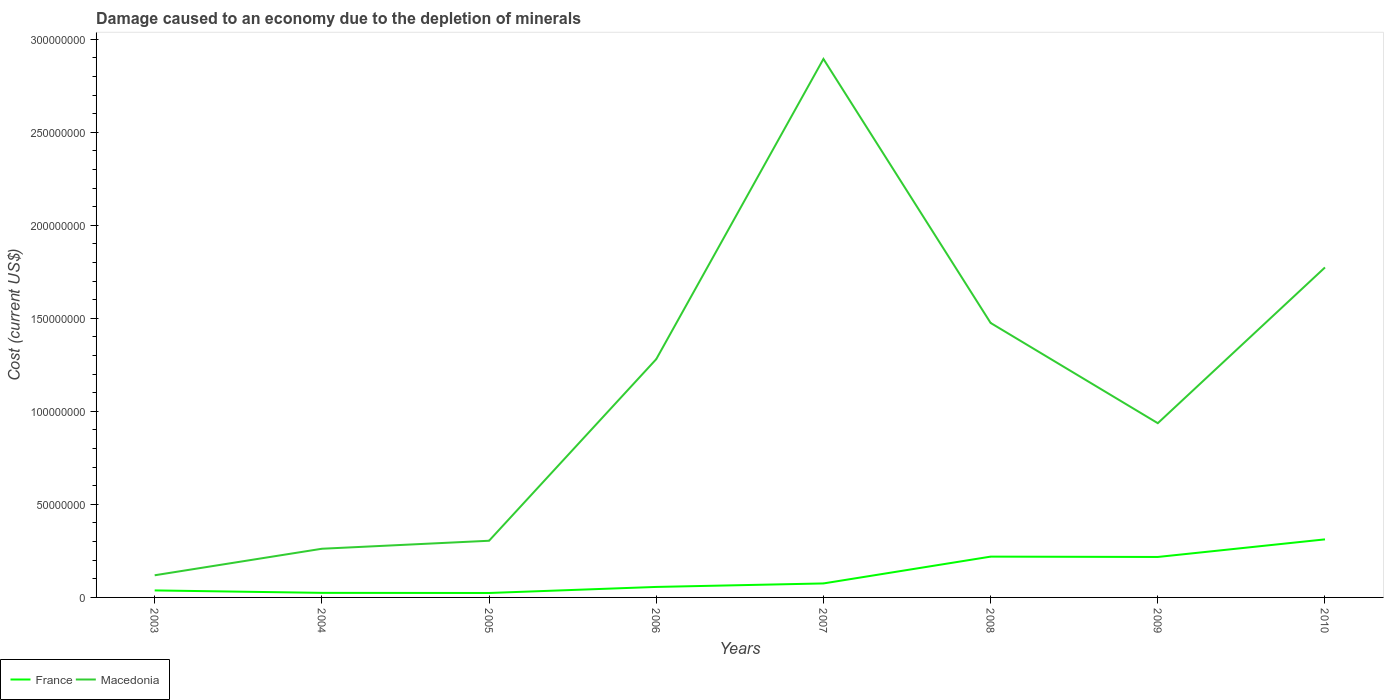Across all years, what is the maximum cost of damage caused due to the depletion of minerals in Macedonia?
Ensure brevity in your answer.  1.19e+07. What is the total cost of damage caused due to the depletion of minerals in France in the graph?
Provide a short and direct response. -3.75e+06. What is the difference between the highest and the second highest cost of damage caused due to the depletion of minerals in France?
Make the answer very short. 2.88e+07. Is the cost of damage caused due to the depletion of minerals in France strictly greater than the cost of damage caused due to the depletion of minerals in Macedonia over the years?
Your response must be concise. Yes. How many years are there in the graph?
Your response must be concise. 8. What is the difference between two consecutive major ticks on the Y-axis?
Offer a terse response. 5.00e+07. Are the values on the major ticks of Y-axis written in scientific E-notation?
Offer a terse response. No. Where does the legend appear in the graph?
Your response must be concise. Bottom left. How many legend labels are there?
Provide a succinct answer. 2. What is the title of the graph?
Give a very brief answer. Damage caused to an economy due to the depletion of minerals. Does "St. Vincent and the Grenadines" appear as one of the legend labels in the graph?
Provide a succinct answer. No. What is the label or title of the Y-axis?
Your answer should be compact. Cost (current US$). What is the Cost (current US$) in France in 2003?
Your answer should be very brief. 3.77e+06. What is the Cost (current US$) in Macedonia in 2003?
Your answer should be compact. 1.19e+07. What is the Cost (current US$) in France in 2004?
Give a very brief answer. 2.46e+06. What is the Cost (current US$) of Macedonia in 2004?
Make the answer very short. 2.62e+07. What is the Cost (current US$) in France in 2005?
Your answer should be compact. 2.39e+06. What is the Cost (current US$) in Macedonia in 2005?
Offer a terse response. 3.05e+07. What is the Cost (current US$) of France in 2006?
Offer a terse response. 5.64e+06. What is the Cost (current US$) of Macedonia in 2006?
Your answer should be compact. 1.28e+08. What is the Cost (current US$) of France in 2007?
Offer a very short reply. 7.52e+06. What is the Cost (current US$) in Macedonia in 2007?
Offer a very short reply. 2.89e+08. What is the Cost (current US$) of France in 2008?
Provide a short and direct response. 2.19e+07. What is the Cost (current US$) of Macedonia in 2008?
Offer a very short reply. 1.48e+08. What is the Cost (current US$) of France in 2009?
Offer a terse response. 2.17e+07. What is the Cost (current US$) of Macedonia in 2009?
Provide a short and direct response. 9.36e+07. What is the Cost (current US$) of France in 2010?
Make the answer very short. 3.12e+07. What is the Cost (current US$) of Macedonia in 2010?
Provide a short and direct response. 1.77e+08. Across all years, what is the maximum Cost (current US$) of France?
Your answer should be compact. 3.12e+07. Across all years, what is the maximum Cost (current US$) in Macedonia?
Your answer should be compact. 2.89e+08. Across all years, what is the minimum Cost (current US$) in France?
Ensure brevity in your answer.  2.39e+06. Across all years, what is the minimum Cost (current US$) in Macedonia?
Offer a terse response. 1.19e+07. What is the total Cost (current US$) of France in the graph?
Provide a short and direct response. 9.66e+07. What is the total Cost (current US$) of Macedonia in the graph?
Offer a very short reply. 9.04e+08. What is the difference between the Cost (current US$) of France in 2003 and that in 2004?
Your answer should be compact. 1.31e+06. What is the difference between the Cost (current US$) in Macedonia in 2003 and that in 2004?
Give a very brief answer. -1.43e+07. What is the difference between the Cost (current US$) of France in 2003 and that in 2005?
Provide a short and direct response. 1.38e+06. What is the difference between the Cost (current US$) in Macedonia in 2003 and that in 2005?
Your answer should be very brief. -1.86e+07. What is the difference between the Cost (current US$) in France in 2003 and that in 2006?
Offer a terse response. -1.88e+06. What is the difference between the Cost (current US$) of Macedonia in 2003 and that in 2006?
Your answer should be very brief. -1.16e+08. What is the difference between the Cost (current US$) in France in 2003 and that in 2007?
Keep it short and to the point. -3.75e+06. What is the difference between the Cost (current US$) of Macedonia in 2003 and that in 2007?
Keep it short and to the point. -2.77e+08. What is the difference between the Cost (current US$) in France in 2003 and that in 2008?
Offer a terse response. -1.82e+07. What is the difference between the Cost (current US$) in Macedonia in 2003 and that in 2008?
Give a very brief answer. -1.36e+08. What is the difference between the Cost (current US$) in France in 2003 and that in 2009?
Your answer should be very brief. -1.80e+07. What is the difference between the Cost (current US$) of Macedonia in 2003 and that in 2009?
Provide a short and direct response. -8.17e+07. What is the difference between the Cost (current US$) in France in 2003 and that in 2010?
Your answer should be very brief. -2.74e+07. What is the difference between the Cost (current US$) in Macedonia in 2003 and that in 2010?
Your answer should be very brief. -1.65e+08. What is the difference between the Cost (current US$) in France in 2004 and that in 2005?
Give a very brief answer. 7.20e+04. What is the difference between the Cost (current US$) of Macedonia in 2004 and that in 2005?
Ensure brevity in your answer.  -4.30e+06. What is the difference between the Cost (current US$) of France in 2004 and that in 2006?
Offer a very short reply. -3.18e+06. What is the difference between the Cost (current US$) in Macedonia in 2004 and that in 2006?
Make the answer very short. -1.02e+08. What is the difference between the Cost (current US$) of France in 2004 and that in 2007?
Your answer should be very brief. -5.06e+06. What is the difference between the Cost (current US$) in Macedonia in 2004 and that in 2007?
Provide a short and direct response. -2.63e+08. What is the difference between the Cost (current US$) in France in 2004 and that in 2008?
Provide a succinct answer. -1.95e+07. What is the difference between the Cost (current US$) of Macedonia in 2004 and that in 2008?
Your answer should be compact. -1.21e+08. What is the difference between the Cost (current US$) of France in 2004 and that in 2009?
Your answer should be compact. -1.93e+07. What is the difference between the Cost (current US$) in Macedonia in 2004 and that in 2009?
Provide a succinct answer. -6.75e+07. What is the difference between the Cost (current US$) of France in 2004 and that in 2010?
Provide a short and direct response. -2.87e+07. What is the difference between the Cost (current US$) in Macedonia in 2004 and that in 2010?
Your answer should be compact. -1.51e+08. What is the difference between the Cost (current US$) in France in 2005 and that in 2006?
Provide a succinct answer. -3.25e+06. What is the difference between the Cost (current US$) in Macedonia in 2005 and that in 2006?
Make the answer very short. -9.76e+07. What is the difference between the Cost (current US$) of France in 2005 and that in 2007?
Provide a succinct answer. -5.13e+06. What is the difference between the Cost (current US$) of Macedonia in 2005 and that in 2007?
Ensure brevity in your answer.  -2.59e+08. What is the difference between the Cost (current US$) in France in 2005 and that in 2008?
Keep it short and to the point. -1.95e+07. What is the difference between the Cost (current US$) of Macedonia in 2005 and that in 2008?
Your response must be concise. -1.17e+08. What is the difference between the Cost (current US$) of France in 2005 and that in 2009?
Offer a very short reply. -1.94e+07. What is the difference between the Cost (current US$) in Macedonia in 2005 and that in 2009?
Provide a succinct answer. -6.32e+07. What is the difference between the Cost (current US$) of France in 2005 and that in 2010?
Your answer should be very brief. -2.88e+07. What is the difference between the Cost (current US$) in Macedonia in 2005 and that in 2010?
Give a very brief answer. -1.47e+08. What is the difference between the Cost (current US$) of France in 2006 and that in 2007?
Offer a very short reply. -1.87e+06. What is the difference between the Cost (current US$) in Macedonia in 2006 and that in 2007?
Your response must be concise. -1.61e+08. What is the difference between the Cost (current US$) in France in 2006 and that in 2008?
Your response must be concise. -1.63e+07. What is the difference between the Cost (current US$) in Macedonia in 2006 and that in 2008?
Offer a terse response. -1.95e+07. What is the difference between the Cost (current US$) of France in 2006 and that in 2009?
Provide a succinct answer. -1.61e+07. What is the difference between the Cost (current US$) of Macedonia in 2006 and that in 2009?
Provide a short and direct response. 3.44e+07. What is the difference between the Cost (current US$) in France in 2006 and that in 2010?
Offer a terse response. -2.56e+07. What is the difference between the Cost (current US$) in Macedonia in 2006 and that in 2010?
Your answer should be compact. -4.93e+07. What is the difference between the Cost (current US$) in France in 2007 and that in 2008?
Your response must be concise. -1.44e+07. What is the difference between the Cost (current US$) of Macedonia in 2007 and that in 2008?
Make the answer very short. 1.42e+08. What is the difference between the Cost (current US$) of France in 2007 and that in 2009?
Your response must be concise. -1.42e+07. What is the difference between the Cost (current US$) of Macedonia in 2007 and that in 2009?
Offer a very short reply. 1.96e+08. What is the difference between the Cost (current US$) of France in 2007 and that in 2010?
Provide a short and direct response. -2.37e+07. What is the difference between the Cost (current US$) of Macedonia in 2007 and that in 2010?
Your response must be concise. 1.12e+08. What is the difference between the Cost (current US$) in France in 2008 and that in 2009?
Make the answer very short. 1.81e+05. What is the difference between the Cost (current US$) of Macedonia in 2008 and that in 2009?
Offer a terse response. 5.39e+07. What is the difference between the Cost (current US$) in France in 2008 and that in 2010?
Provide a short and direct response. -9.28e+06. What is the difference between the Cost (current US$) in Macedonia in 2008 and that in 2010?
Ensure brevity in your answer.  -2.98e+07. What is the difference between the Cost (current US$) of France in 2009 and that in 2010?
Offer a very short reply. -9.46e+06. What is the difference between the Cost (current US$) of Macedonia in 2009 and that in 2010?
Your response must be concise. -8.37e+07. What is the difference between the Cost (current US$) of France in 2003 and the Cost (current US$) of Macedonia in 2004?
Offer a terse response. -2.24e+07. What is the difference between the Cost (current US$) of France in 2003 and the Cost (current US$) of Macedonia in 2005?
Your answer should be very brief. -2.67e+07. What is the difference between the Cost (current US$) in France in 2003 and the Cost (current US$) in Macedonia in 2006?
Offer a terse response. -1.24e+08. What is the difference between the Cost (current US$) in France in 2003 and the Cost (current US$) in Macedonia in 2007?
Provide a short and direct response. -2.86e+08. What is the difference between the Cost (current US$) in France in 2003 and the Cost (current US$) in Macedonia in 2008?
Your answer should be compact. -1.44e+08. What is the difference between the Cost (current US$) of France in 2003 and the Cost (current US$) of Macedonia in 2009?
Provide a succinct answer. -8.99e+07. What is the difference between the Cost (current US$) of France in 2003 and the Cost (current US$) of Macedonia in 2010?
Offer a very short reply. -1.74e+08. What is the difference between the Cost (current US$) in France in 2004 and the Cost (current US$) in Macedonia in 2005?
Offer a very short reply. -2.80e+07. What is the difference between the Cost (current US$) of France in 2004 and the Cost (current US$) of Macedonia in 2006?
Provide a short and direct response. -1.26e+08. What is the difference between the Cost (current US$) in France in 2004 and the Cost (current US$) in Macedonia in 2007?
Offer a terse response. -2.87e+08. What is the difference between the Cost (current US$) of France in 2004 and the Cost (current US$) of Macedonia in 2008?
Make the answer very short. -1.45e+08. What is the difference between the Cost (current US$) in France in 2004 and the Cost (current US$) in Macedonia in 2009?
Give a very brief answer. -9.12e+07. What is the difference between the Cost (current US$) in France in 2004 and the Cost (current US$) in Macedonia in 2010?
Make the answer very short. -1.75e+08. What is the difference between the Cost (current US$) in France in 2005 and the Cost (current US$) in Macedonia in 2006?
Keep it short and to the point. -1.26e+08. What is the difference between the Cost (current US$) in France in 2005 and the Cost (current US$) in Macedonia in 2007?
Provide a short and direct response. -2.87e+08. What is the difference between the Cost (current US$) in France in 2005 and the Cost (current US$) in Macedonia in 2008?
Provide a succinct answer. -1.45e+08. What is the difference between the Cost (current US$) of France in 2005 and the Cost (current US$) of Macedonia in 2009?
Offer a very short reply. -9.13e+07. What is the difference between the Cost (current US$) of France in 2005 and the Cost (current US$) of Macedonia in 2010?
Your answer should be compact. -1.75e+08. What is the difference between the Cost (current US$) in France in 2006 and the Cost (current US$) in Macedonia in 2007?
Provide a succinct answer. -2.84e+08. What is the difference between the Cost (current US$) in France in 2006 and the Cost (current US$) in Macedonia in 2008?
Offer a terse response. -1.42e+08. What is the difference between the Cost (current US$) of France in 2006 and the Cost (current US$) of Macedonia in 2009?
Your answer should be very brief. -8.80e+07. What is the difference between the Cost (current US$) of France in 2006 and the Cost (current US$) of Macedonia in 2010?
Give a very brief answer. -1.72e+08. What is the difference between the Cost (current US$) of France in 2007 and the Cost (current US$) of Macedonia in 2008?
Your response must be concise. -1.40e+08. What is the difference between the Cost (current US$) of France in 2007 and the Cost (current US$) of Macedonia in 2009?
Your response must be concise. -8.61e+07. What is the difference between the Cost (current US$) of France in 2007 and the Cost (current US$) of Macedonia in 2010?
Keep it short and to the point. -1.70e+08. What is the difference between the Cost (current US$) of France in 2008 and the Cost (current US$) of Macedonia in 2009?
Make the answer very short. -7.17e+07. What is the difference between the Cost (current US$) in France in 2008 and the Cost (current US$) in Macedonia in 2010?
Your response must be concise. -1.55e+08. What is the difference between the Cost (current US$) of France in 2009 and the Cost (current US$) of Macedonia in 2010?
Provide a succinct answer. -1.56e+08. What is the average Cost (current US$) in France per year?
Make the answer very short. 1.21e+07. What is the average Cost (current US$) of Macedonia per year?
Make the answer very short. 1.13e+08. In the year 2003, what is the difference between the Cost (current US$) of France and Cost (current US$) of Macedonia?
Ensure brevity in your answer.  -8.14e+06. In the year 2004, what is the difference between the Cost (current US$) of France and Cost (current US$) of Macedonia?
Your answer should be very brief. -2.37e+07. In the year 2005, what is the difference between the Cost (current US$) of France and Cost (current US$) of Macedonia?
Offer a very short reply. -2.81e+07. In the year 2006, what is the difference between the Cost (current US$) in France and Cost (current US$) in Macedonia?
Ensure brevity in your answer.  -1.22e+08. In the year 2007, what is the difference between the Cost (current US$) of France and Cost (current US$) of Macedonia?
Your answer should be very brief. -2.82e+08. In the year 2008, what is the difference between the Cost (current US$) in France and Cost (current US$) in Macedonia?
Your answer should be very brief. -1.26e+08. In the year 2009, what is the difference between the Cost (current US$) of France and Cost (current US$) of Macedonia?
Provide a short and direct response. -7.19e+07. In the year 2010, what is the difference between the Cost (current US$) in France and Cost (current US$) in Macedonia?
Give a very brief answer. -1.46e+08. What is the ratio of the Cost (current US$) of France in 2003 to that in 2004?
Your answer should be compact. 1.53. What is the ratio of the Cost (current US$) in Macedonia in 2003 to that in 2004?
Your response must be concise. 0.46. What is the ratio of the Cost (current US$) in France in 2003 to that in 2005?
Your answer should be very brief. 1.58. What is the ratio of the Cost (current US$) of Macedonia in 2003 to that in 2005?
Offer a very short reply. 0.39. What is the ratio of the Cost (current US$) in France in 2003 to that in 2006?
Provide a succinct answer. 0.67. What is the ratio of the Cost (current US$) of Macedonia in 2003 to that in 2006?
Your answer should be compact. 0.09. What is the ratio of the Cost (current US$) in France in 2003 to that in 2007?
Make the answer very short. 0.5. What is the ratio of the Cost (current US$) of Macedonia in 2003 to that in 2007?
Make the answer very short. 0.04. What is the ratio of the Cost (current US$) of France in 2003 to that in 2008?
Provide a short and direct response. 0.17. What is the ratio of the Cost (current US$) of Macedonia in 2003 to that in 2008?
Offer a terse response. 0.08. What is the ratio of the Cost (current US$) in France in 2003 to that in 2009?
Your response must be concise. 0.17. What is the ratio of the Cost (current US$) of Macedonia in 2003 to that in 2009?
Provide a succinct answer. 0.13. What is the ratio of the Cost (current US$) in France in 2003 to that in 2010?
Give a very brief answer. 0.12. What is the ratio of the Cost (current US$) in Macedonia in 2003 to that in 2010?
Provide a short and direct response. 0.07. What is the ratio of the Cost (current US$) of France in 2004 to that in 2005?
Make the answer very short. 1.03. What is the ratio of the Cost (current US$) in Macedonia in 2004 to that in 2005?
Make the answer very short. 0.86. What is the ratio of the Cost (current US$) in France in 2004 to that in 2006?
Offer a terse response. 0.44. What is the ratio of the Cost (current US$) of Macedonia in 2004 to that in 2006?
Offer a terse response. 0.2. What is the ratio of the Cost (current US$) of France in 2004 to that in 2007?
Give a very brief answer. 0.33. What is the ratio of the Cost (current US$) of Macedonia in 2004 to that in 2007?
Make the answer very short. 0.09. What is the ratio of the Cost (current US$) in France in 2004 to that in 2008?
Your answer should be very brief. 0.11. What is the ratio of the Cost (current US$) of Macedonia in 2004 to that in 2008?
Give a very brief answer. 0.18. What is the ratio of the Cost (current US$) of France in 2004 to that in 2009?
Your response must be concise. 0.11. What is the ratio of the Cost (current US$) in Macedonia in 2004 to that in 2009?
Ensure brevity in your answer.  0.28. What is the ratio of the Cost (current US$) in France in 2004 to that in 2010?
Give a very brief answer. 0.08. What is the ratio of the Cost (current US$) in Macedonia in 2004 to that in 2010?
Give a very brief answer. 0.15. What is the ratio of the Cost (current US$) in France in 2005 to that in 2006?
Make the answer very short. 0.42. What is the ratio of the Cost (current US$) of Macedonia in 2005 to that in 2006?
Offer a very short reply. 0.24. What is the ratio of the Cost (current US$) in France in 2005 to that in 2007?
Give a very brief answer. 0.32. What is the ratio of the Cost (current US$) in Macedonia in 2005 to that in 2007?
Ensure brevity in your answer.  0.11. What is the ratio of the Cost (current US$) of France in 2005 to that in 2008?
Provide a succinct answer. 0.11. What is the ratio of the Cost (current US$) of Macedonia in 2005 to that in 2008?
Give a very brief answer. 0.21. What is the ratio of the Cost (current US$) in France in 2005 to that in 2009?
Your answer should be very brief. 0.11. What is the ratio of the Cost (current US$) in Macedonia in 2005 to that in 2009?
Give a very brief answer. 0.33. What is the ratio of the Cost (current US$) in France in 2005 to that in 2010?
Your response must be concise. 0.08. What is the ratio of the Cost (current US$) in Macedonia in 2005 to that in 2010?
Ensure brevity in your answer.  0.17. What is the ratio of the Cost (current US$) in France in 2006 to that in 2007?
Keep it short and to the point. 0.75. What is the ratio of the Cost (current US$) in Macedonia in 2006 to that in 2007?
Make the answer very short. 0.44. What is the ratio of the Cost (current US$) in France in 2006 to that in 2008?
Keep it short and to the point. 0.26. What is the ratio of the Cost (current US$) in Macedonia in 2006 to that in 2008?
Make the answer very short. 0.87. What is the ratio of the Cost (current US$) in France in 2006 to that in 2009?
Your answer should be compact. 0.26. What is the ratio of the Cost (current US$) of Macedonia in 2006 to that in 2009?
Your answer should be very brief. 1.37. What is the ratio of the Cost (current US$) of France in 2006 to that in 2010?
Provide a short and direct response. 0.18. What is the ratio of the Cost (current US$) of Macedonia in 2006 to that in 2010?
Provide a succinct answer. 0.72. What is the ratio of the Cost (current US$) of France in 2007 to that in 2008?
Give a very brief answer. 0.34. What is the ratio of the Cost (current US$) in Macedonia in 2007 to that in 2008?
Give a very brief answer. 1.96. What is the ratio of the Cost (current US$) of France in 2007 to that in 2009?
Offer a very short reply. 0.35. What is the ratio of the Cost (current US$) in Macedonia in 2007 to that in 2009?
Your answer should be very brief. 3.09. What is the ratio of the Cost (current US$) of France in 2007 to that in 2010?
Your response must be concise. 0.24. What is the ratio of the Cost (current US$) in Macedonia in 2007 to that in 2010?
Keep it short and to the point. 1.63. What is the ratio of the Cost (current US$) in France in 2008 to that in 2009?
Your answer should be compact. 1.01. What is the ratio of the Cost (current US$) in Macedonia in 2008 to that in 2009?
Make the answer very short. 1.58. What is the ratio of the Cost (current US$) in France in 2008 to that in 2010?
Your answer should be compact. 0.7. What is the ratio of the Cost (current US$) of Macedonia in 2008 to that in 2010?
Your answer should be compact. 0.83. What is the ratio of the Cost (current US$) in France in 2009 to that in 2010?
Make the answer very short. 0.7. What is the ratio of the Cost (current US$) of Macedonia in 2009 to that in 2010?
Offer a terse response. 0.53. What is the difference between the highest and the second highest Cost (current US$) in France?
Offer a very short reply. 9.28e+06. What is the difference between the highest and the second highest Cost (current US$) in Macedonia?
Offer a very short reply. 1.12e+08. What is the difference between the highest and the lowest Cost (current US$) of France?
Your response must be concise. 2.88e+07. What is the difference between the highest and the lowest Cost (current US$) of Macedonia?
Your answer should be very brief. 2.77e+08. 